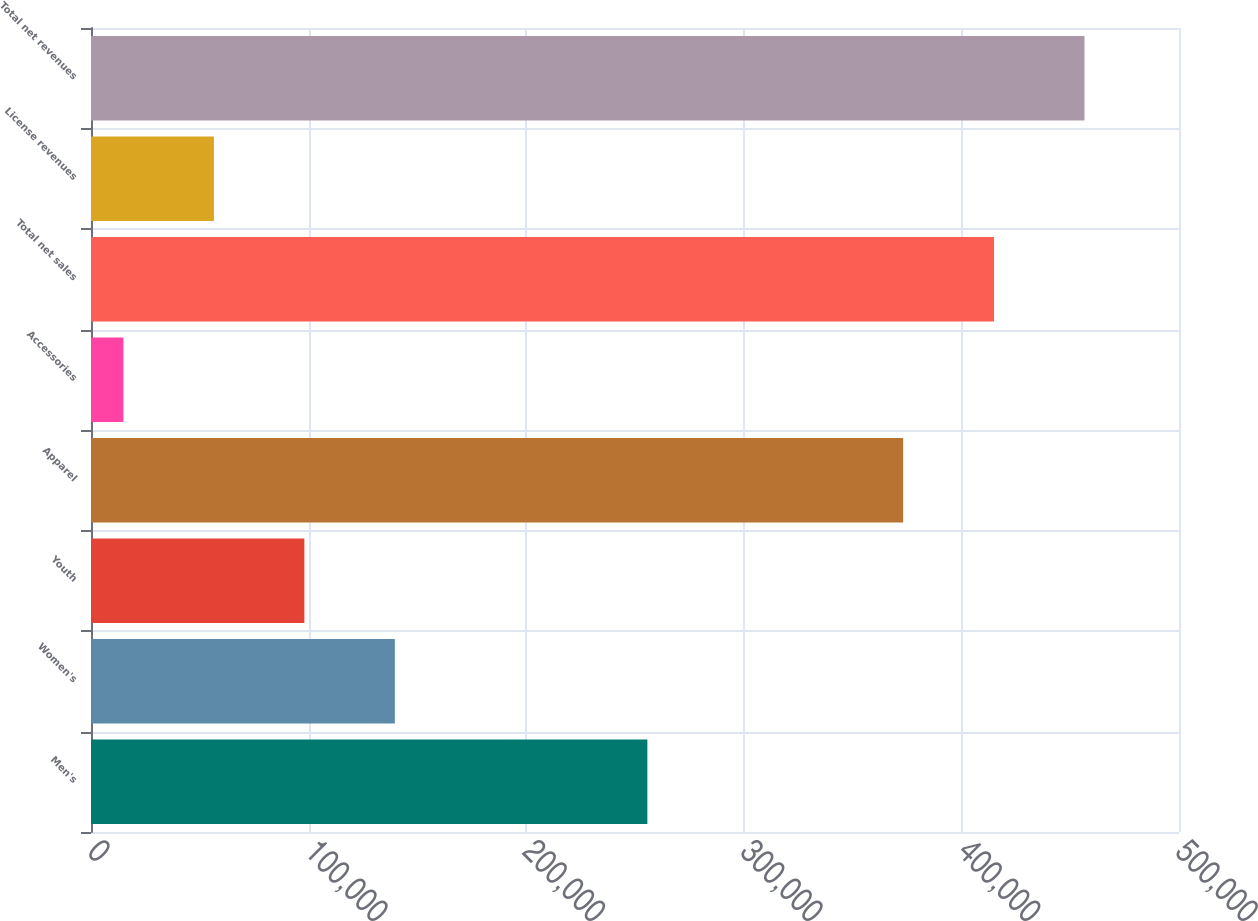Convert chart to OTSL. <chart><loc_0><loc_0><loc_500><loc_500><bar_chart><fcel>Men's<fcel>Women's<fcel>Youth<fcel>Apparel<fcel>Accessories<fcel>Total net sales<fcel>License revenues<fcel>Total net revenues<nl><fcel>255681<fcel>139635<fcel>98055.4<fcel>373221<fcel>14897<fcel>414992<fcel>56476.2<fcel>456571<nl></chart> 